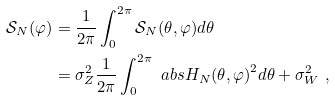Convert formula to latex. <formula><loc_0><loc_0><loc_500><loc_500>\mathcal { S } _ { N } ( \varphi ) & = \frac { 1 } { 2 \pi } \int _ { 0 } ^ { 2 \pi } \mathcal { S } _ { N } ( \theta , \varphi ) d \theta \\ & = \sigma ^ { 2 } _ { Z } \frac { 1 } { 2 \pi } \int _ { 0 } ^ { 2 \pi } \ a b s { H _ { N } ( \theta , \varphi ) } ^ { 2 } d \theta + \sigma ^ { 2 } _ { W } \ ,</formula> 